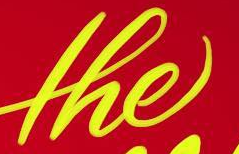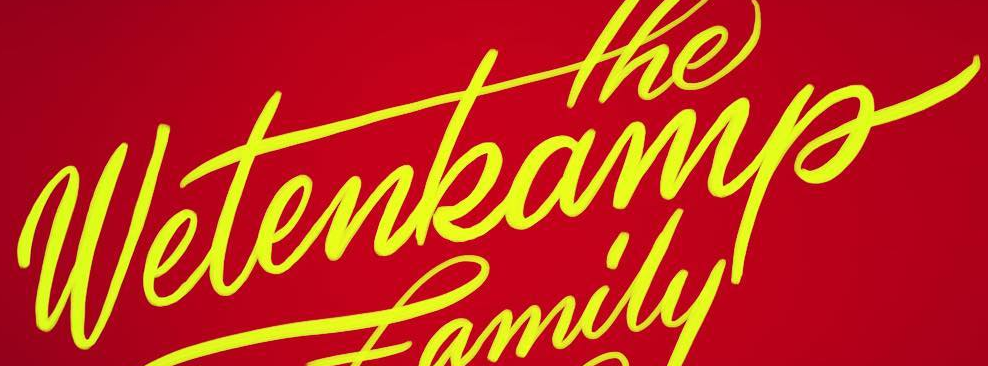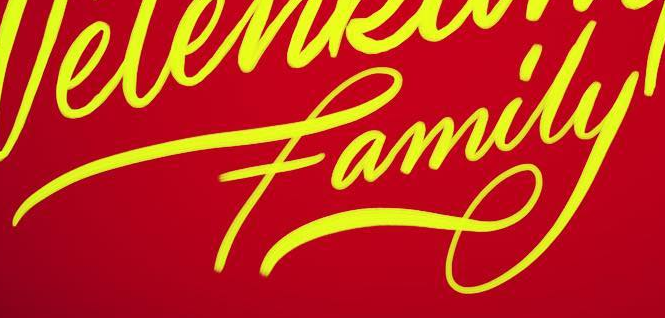Transcribe the words shown in these images in order, separated by a semicolon. the; wetenkamp; family 